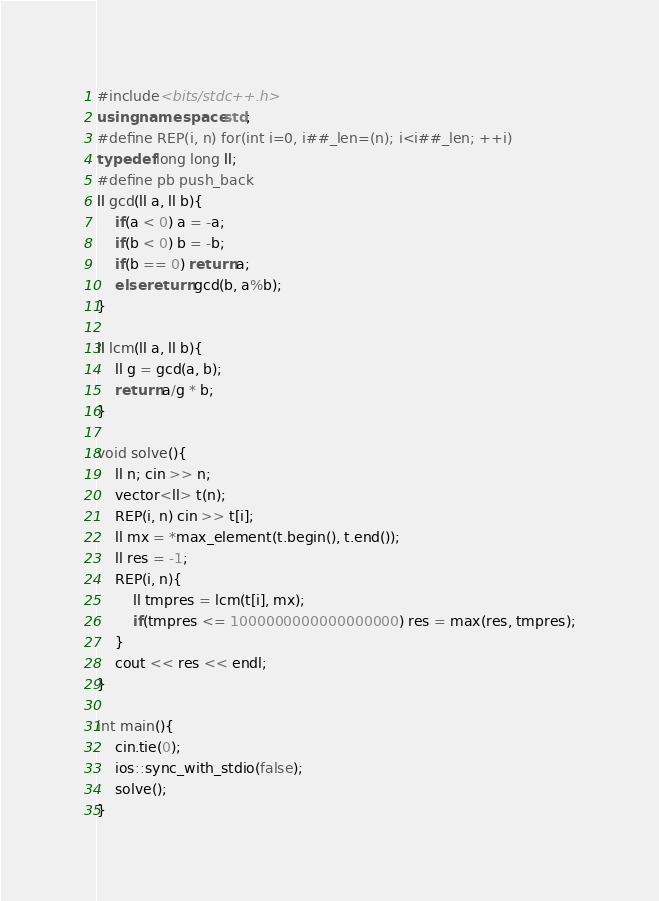<code> <loc_0><loc_0><loc_500><loc_500><_C++_>#include<bits/stdc++.h>
using namespace std;
#define REP(i, n) for(int i=0, i##_len=(n); i<i##_len; ++i)
typedef long long ll;
#define pb push_back
ll gcd(ll a, ll b){
    if(a < 0) a = -a;
    if(b < 0) b = -b;
    if(b == 0) return a;
    else return gcd(b, a%b);
}

ll lcm(ll a, ll b){
    ll g = gcd(a, b);
    return a/g * b;
}

void solve(){
    ll n; cin >> n;
    vector<ll> t(n);
    REP(i, n) cin >> t[i];
    ll mx = *max_element(t.begin(), t.end());
    ll res = -1;
    REP(i, n){
        ll tmpres = lcm(t[i], mx);
        if(tmpres <= 1000000000000000000) res = max(res, tmpres);
    }
    cout << res << endl;
}

int main(){
    cin.tie(0);
    ios::sync_with_stdio(false);
    solve();
}</code> 